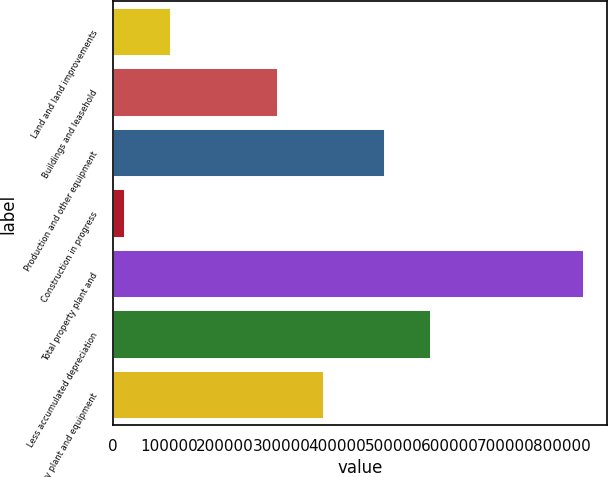Convert chart to OTSL. <chart><loc_0><loc_0><loc_500><loc_500><bar_chart><fcel>Land and land improvements<fcel>Buildings and leasehold<fcel>Production and other equipment<fcel>Construction in progress<fcel>Total property plant and<fcel>Less accumulated depreciation<fcel>Property plant and equipment<nl><fcel>103762<fcel>294219<fcel>484475<fcel>22140<fcel>838359<fcel>566097<fcel>375841<nl></chart> 